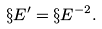<formula> <loc_0><loc_0><loc_500><loc_500>\S E ^ { \prime } = \S E ^ { - 2 } .</formula> 